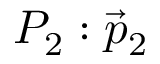<formula> <loc_0><loc_0><loc_500><loc_500>P _ { 2 } \colon { \vec { p } } _ { 2 }</formula> 